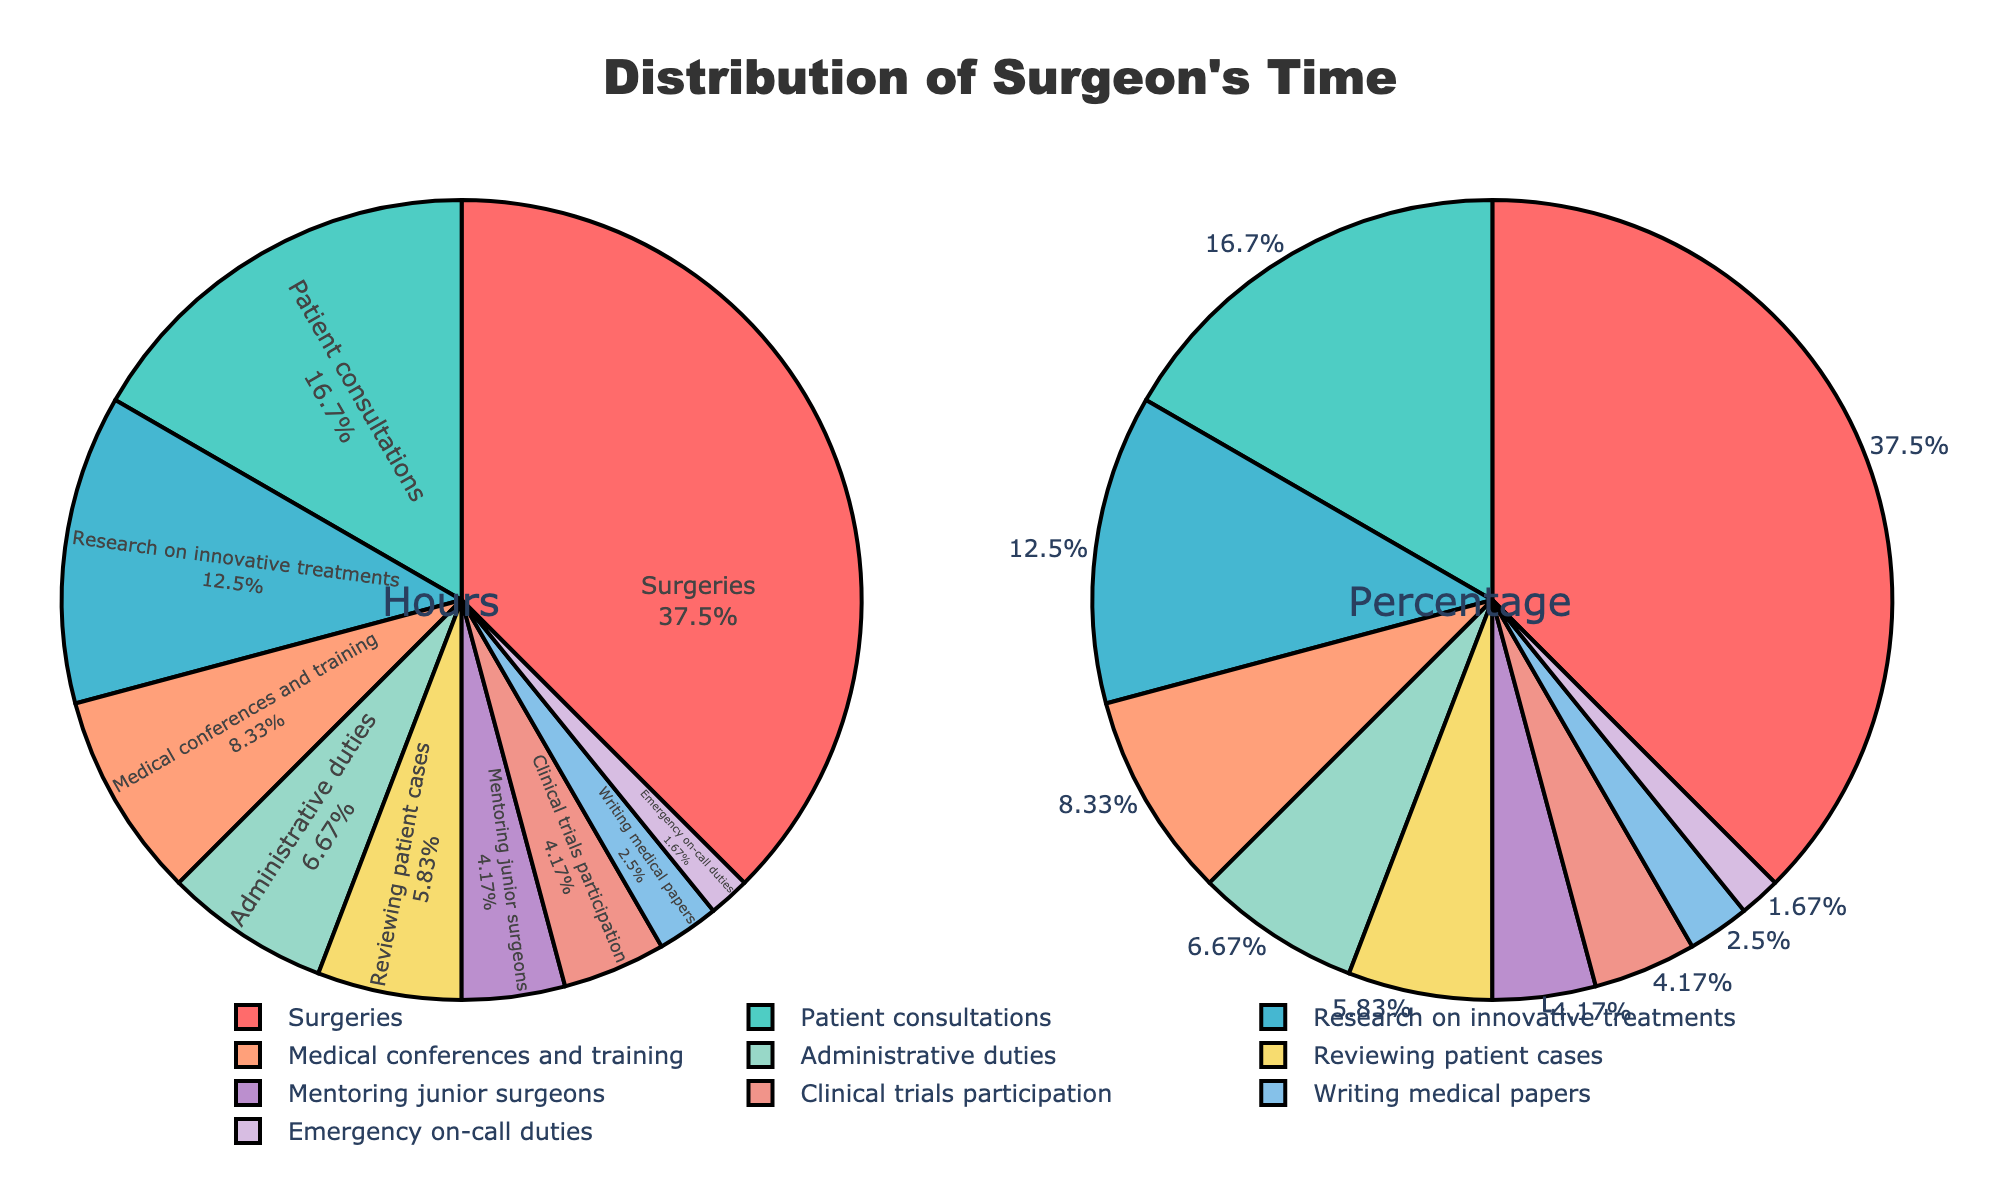Which activity does the surgeon spend the most time on? The figure shows that "Surgeries" has the largest segment in the pie chart for both hours and percentage.
Answer: Surgeries Which two activities have the smallest amount of time spent by the surgeon? By examining the smallest segments in the pie chart, we can see that "Writing medical papers" and "Emergency on-call duties" are the smallest.
Answer: Writing medical papers and Emergency on-call duties What is the combined percentage of time spent on 'Surgeries' and 'Patient consultations'? The pie chart for hours shows 'Surgeries' at 45 hours and 'Patient consultations' at 20 hours. Adding their hours gives 65 hours. Since the total is 120 hours, the combined percentage is (65/120) * 100 = 54.17%.
Answer: 54.17% Does the surgeon spend more time on 'Research on innovative treatments' or 'Medical conferences and training'? Comparing the segments in the pie chart, 'Research on innovative treatments' is larger than 'Medical conferences and training', which indicates more hours are spent on research.
Answer: Research on innovative treatments What is the ratio of time spent on 'Mentoring junior surgeons' to 'Administrative duties'? The pie chart for hours indicates 5 hours on 'Mentoring junior surgeons' and 8 hours on 'Administrative duties'. The ratio is 5:8.
Answer: 5:8 How much more time does the surgeon spend on 'Administrative duties' than 'Reviewing patient cases'? The hours for 'Administrative duties' (8) and 'Reviewing patient cases' (7) are shown in the pie chart. The difference is 8 - 7 = 1 hour.
Answer: 1 hour Which activity has the closest percentage to 'Medical conferences and training'? By observing the pie chart for percentages, 'Reviewing patient cases' (approximately 5.83%) is closest to 'Medical conferences and training' (approximately 8.33%).
Answer: Reviewing patient cases What percentage of time does the surgeon spend on activities related to direct patient interaction (Surgeries and Patient consultations)? Adding the percentages from the pie chart for 'Surgeries' (45/120 * 100 = 37.5%) and 'Patient consultations' (20/120 * 100 = 16.67%), the total is 37.5% + 16.67% = 54.17%.
Answer: 54.17% Is the time spent on 'Clinical trials participation' more or less than a tenth of the total time? The figure shows that 'Clinical trials participation' is 5 hours, and the total is 120 hours. One tenth of 120 is 12, and 5 is less than 12.
Answer: Less What is the median value of hours spent on all activities? Listing all hours in ascending order: 2, 3, 5, 5, 7, 8, 10, 15, 20, 45. The two middle numbers are 7 and 8, so the median is (7+8)/2 = 7.5.
Answer: 7.5 